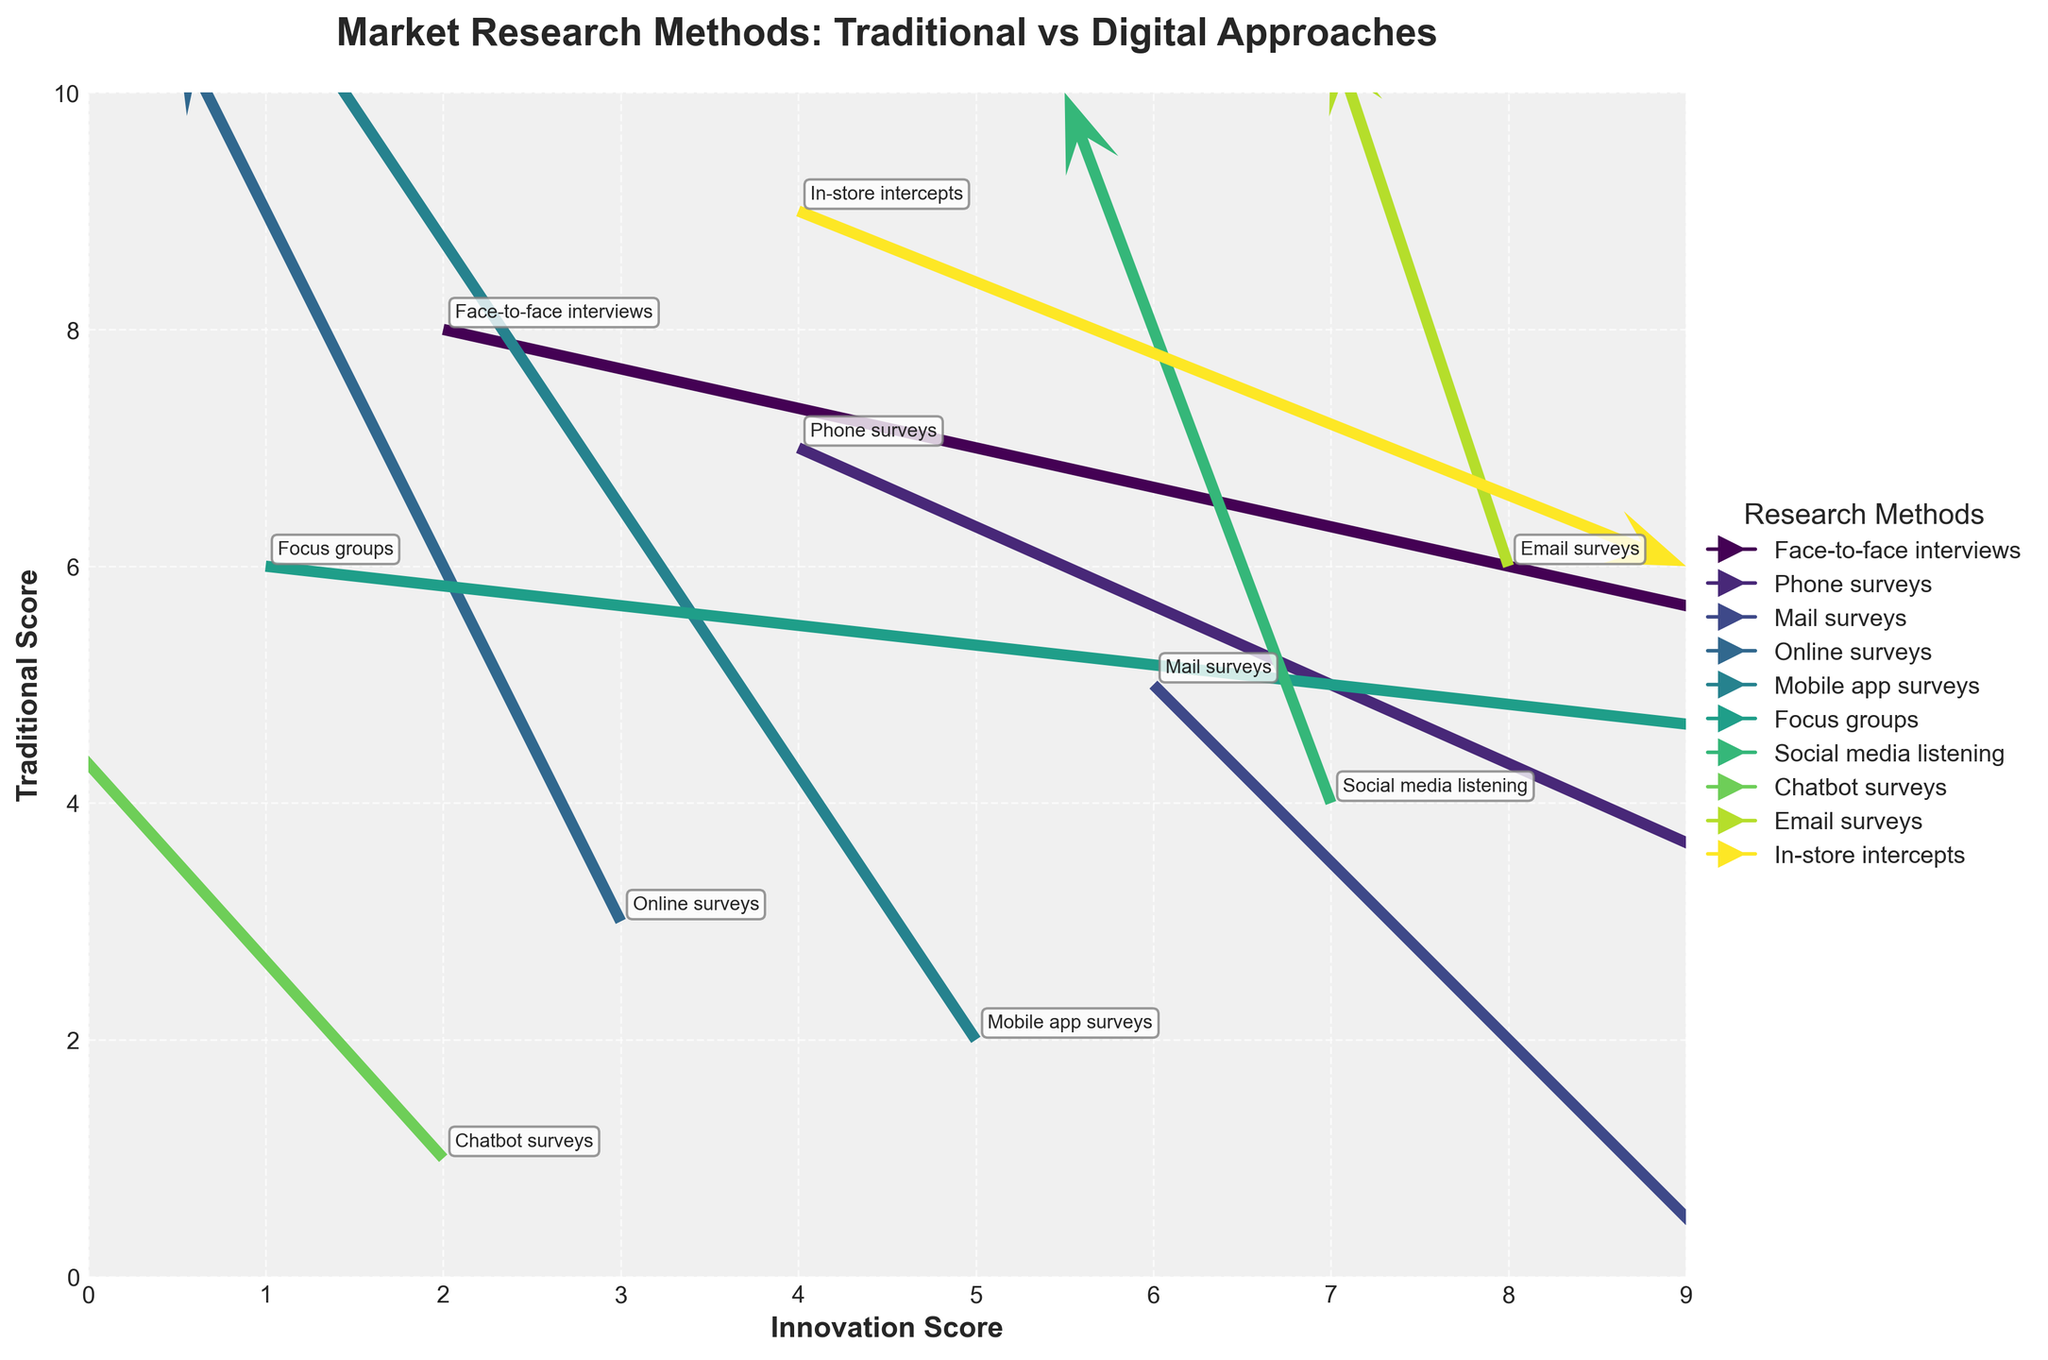What are the labels on the x-axis and y-axis? The x-axis label is "Innovation Score" and the y-axis label is "Traditional Score". We can see this because the labels are printed directly below the x-axis and beside the y-axis.
Answer: Innovation Score, Traditional Score What is the title of the quiver plot? The title is displayed at the top center of the plot in bold font, and it reads "Market Research Methods: Traditional vs Digital Approaches".
Answer: Market Research Methods: Traditional vs Digital Approaches How many methods are represented in the quiver plot? By counting the number of distinct quivers and their annotations in the plot, we observe that 10 methods are represented. Each method is annotated with its name.
Answer: 10 Which research method indicates the highest positive shift on the x-axis? The quiver for "Focus groups" shows the highest positive shift on the x-axis. The arrow direction for Focus groups is predominantly horizontal towards the right, starting from (1, 6).
Answer: Focus groups Which research method shows the largest negative shift on the y-axis? By examining the downward arrow lengths, "Phone surveys" shows the largest negative shift on the y-axis with an arrow pointing downwards starting from (4, 7).
Answer: Phone surveys Which method has the most significant positive shift on the y-axis? "Chatbot surveys" has the most significant positive shift on the y-axis, as it shows the arrow pointing significantly upwards, starting from (2, 1).
Answer: Chatbot surveys Identify the methods that are represented in both digital and traditional research approaches. Reviewing the annotations and corresponding methods, we can see that "Online surveys", "Mobile app surveys", "Social media listening", "Chatbot surveys", and "Email surveys" are digital methods, while the rest are traditional. This can be deduced from the method names and their association with digital or traditional means.
Answer: Online surveys, Mobile app surveys, Social media listening, Chatbot surveys, Email surveys Which research methods have almost no movement on the x-axis but a noticeable positive shift on the y-axis? By observing the arrows close to vertical in direction, "Social media listening" and "Email surveys" have negligible movement on the x-axis but noticeable positive shifts on the y-axis. The arrows for these methods show upward movement without a horizontal shift.
Answer: Social media listening, Email surveys Compare the shift in productivity between face-to-face interviews and mobile app surveys. "Face-to-face interviews" quiver starts at (2, 8) and moves to the right indicating a positive x-shift, while "Mobile app surveys" quiver starts at (5, 2) and shifts not only slightly left but more upwards. Thus, Face-to-face interviews are increasing more in innovation, while Mobile app surveys show more increase in traditional metrics.
Answer: Face-to-face interviews: more x-shift; Mobile app surveys: more y-shift How do In-store intercepts compare to Email surveys in terms of shift direction? "In-store intercepts" arrow shows a rightward shift with a slight downward movement starting from (4, 9). On the other hand, "Email surveys" demonstrate a rightward shift and upward movement starting from (8, 6). Therefore, In-store intercepts generally show a decrease in traditional scores while increasing innovation scores, whereas Email surveys increase both.
Answer: In-store intercepts: rightward and slightly downward; Email surveys: rightward and upward 